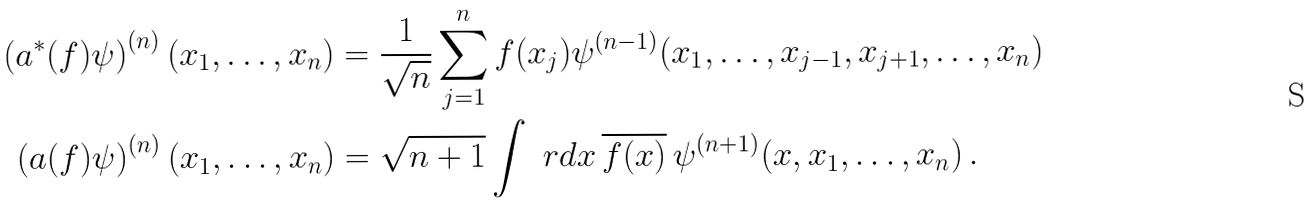Convert formula to latex. <formula><loc_0><loc_0><loc_500><loc_500>\left ( a ^ { * } ( f ) \psi \right ) ^ { ( n ) } ( x _ { 1 } , \dots , x _ { n } ) & = \frac { 1 } { \sqrt { n } } \sum _ { j = 1 } ^ { n } f ( x _ { j } ) \psi ^ { ( n - 1 ) } ( x _ { 1 } , \dots , x _ { j - 1 } , x _ { j + 1 } , \dots , x _ { n } ) \\ \left ( a ( f ) \psi \right ) ^ { ( n ) } ( x _ { 1 } , \dots , x _ { n } ) & = \sqrt { n + 1 } \int \ r d x \, \overline { f ( x ) } \, \psi ^ { ( n + 1 ) } ( x , x _ { 1 } , \dots , x _ { n } ) \, .</formula> 